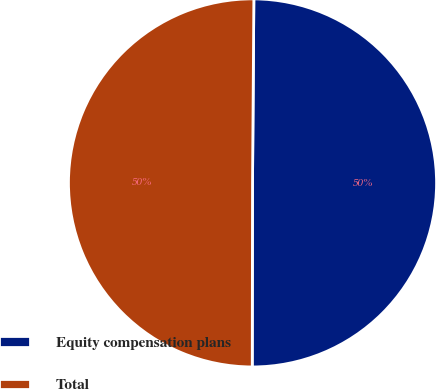Convert chart to OTSL. <chart><loc_0><loc_0><loc_500><loc_500><pie_chart><fcel>Equity compensation plans<fcel>Total<nl><fcel>49.91%<fcel>50.09%<nl></chart> 